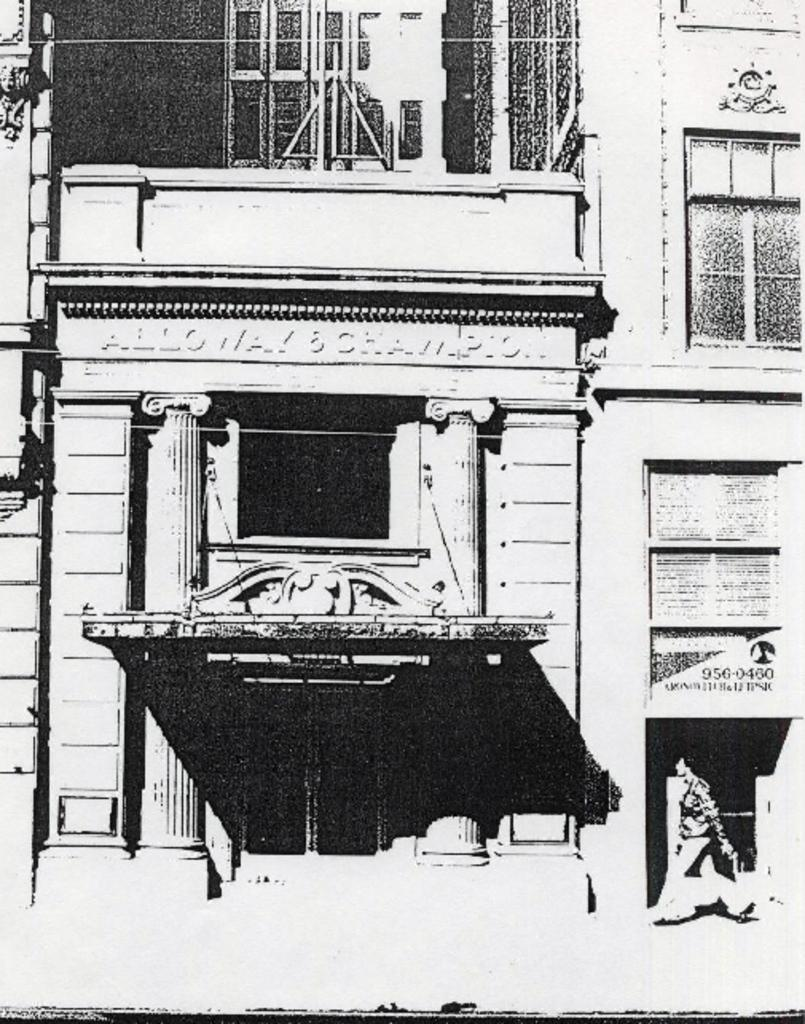What is the color scheme of the image? The image is black and white. What is the main subject of the image? There is a building in the image. What are some features of the building? The building has walls, windows, roofs, and pillars. Is there any text or name on the building? Yes, there is a name on the building. Are there any people in the image? Yes, there is a person walking in the image. What type of fowl can be seen flying near the building in the image? There are no fowl visible in the image; it is a black and white image of a building with a person walking. Are there any police officers present in the image? There is no indication of police officers in the image, as it only features a building, a person walking, and the building's features. 